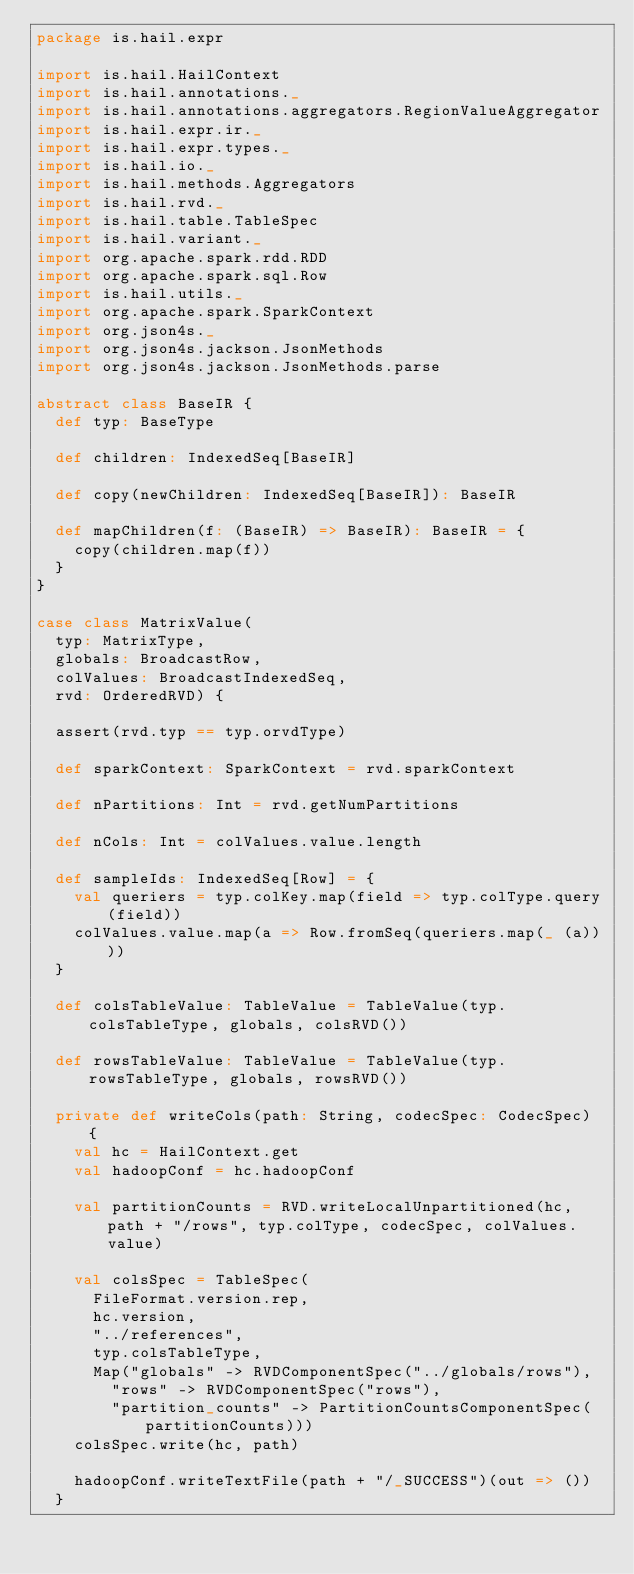<code> <loc_0><loc_0><loc_500><loc_500><_Scala_>package is.hail.expr

import is.hail.HailContext
import is.hail.annotations._
import is.hail.annotations.aggregators.RegionValueAggregator
import is.hail.expr.ir._
import is.hail.expr.types._
import is.hail.io._
import is.hail.methods.Aggregators
import is.hail.rvd._
import is.hail.table.TableSpec
import is.hail.variant._
import org.apache.spark.rdd.RDD
import org.apache.spark.sql.Row
import is.hail.utils._
import org.apache.spark.SparkContext
import org.json4s._
import org.json4s.jackson.JsonMethods
import org.json4s.jackson.JsonMethods.parse

abstract class BaseIR {
  def typ: BaseType

  def children: IndexedSeq[BaseIR]

  def copy(newChildren: IndexedSeq[BaseIR]): BaseIR

  def mapChildren(f: (BaseIR) => BaseIR): BaseIR = {
    copy(children.map(f))
  }
}

case class MatrixValue(
  typ: MatrixType,
  globals: BroadcastRow,
  colValues: BroadcastIndexedSeq,
  rvd: OrderedRVD) {

  assert(rvd.typ == typ.orvdType)

  def sparkContext: SparkContext = rvd.sparkContext

  def nPartitions: Int = rvd.getNumPartitions

  def nCols: Int = colValues.value.length

  def sampleIds: IndexedSeq[Row] = {
    val queriers = typ.colKey.map(field => typ.colType.query(field))
    colValues.value.map(a => Row.fromSeq(queriers.map(_ (a))))
  }

  def colsTableValue: TableValue = TableValue(typ.colsTableType, globals, colsRVD())

  def rowsTableValue: TableValue = TableValue(typ.rowsTableType, globals, rowsRVD())

  private def writeCols(path: String, codecSpec: CodecSpec) {
    val hc = HailContext.get
    val hadoopConf = hc.hadoopConf

    val partitionCounts = RVD.writeLocalUnpartitioned(hc, path + "/rows", typ.colType, codecSpec, colValues.value)

    val colsSpec = TableSpec(
      FileFormat.version.rep,
      hc.version,
      "../references",
      typ.colsTableType,
      Map("globals" -> RVDComponentSpec("../globals/rows"),
        "rows" -> RVDComponentSpec("rows"),
        "partition_counts" -> PartitionCountsComponentSpec(partitionCounts)))
    colsSpec.write(hc, path)

    hadoopConf.writeTextFile(path + "/_SUCCESS")(out => ())
  }
</code> 